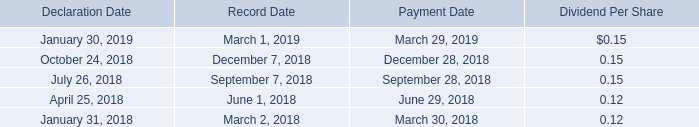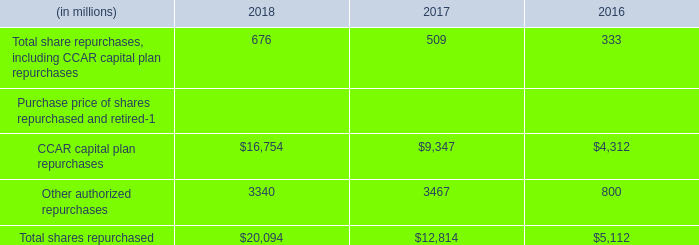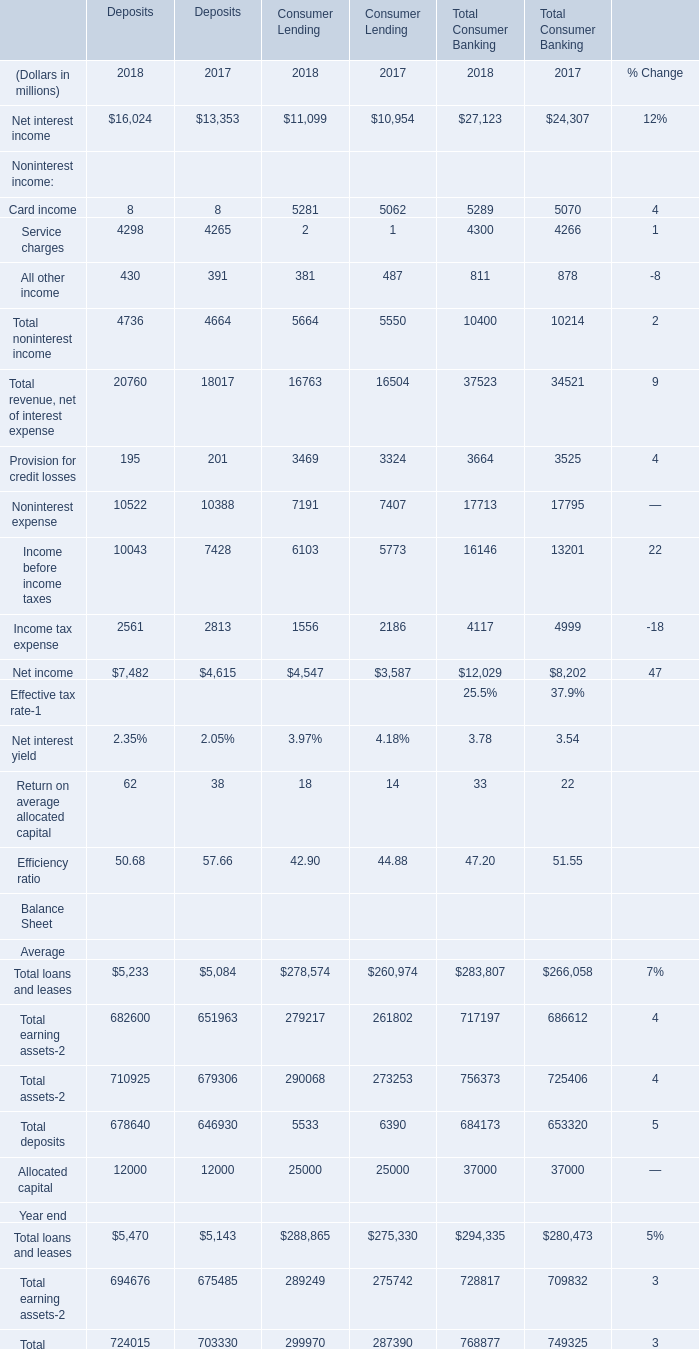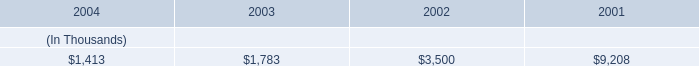What is the growing rate of All other income in the year with the most Net interest income? 
Computations: ((((430 + 381) + 811) - ((391 + 487) + 878)) / ((391 + 487) + 878))
Answer: -0.07631. 